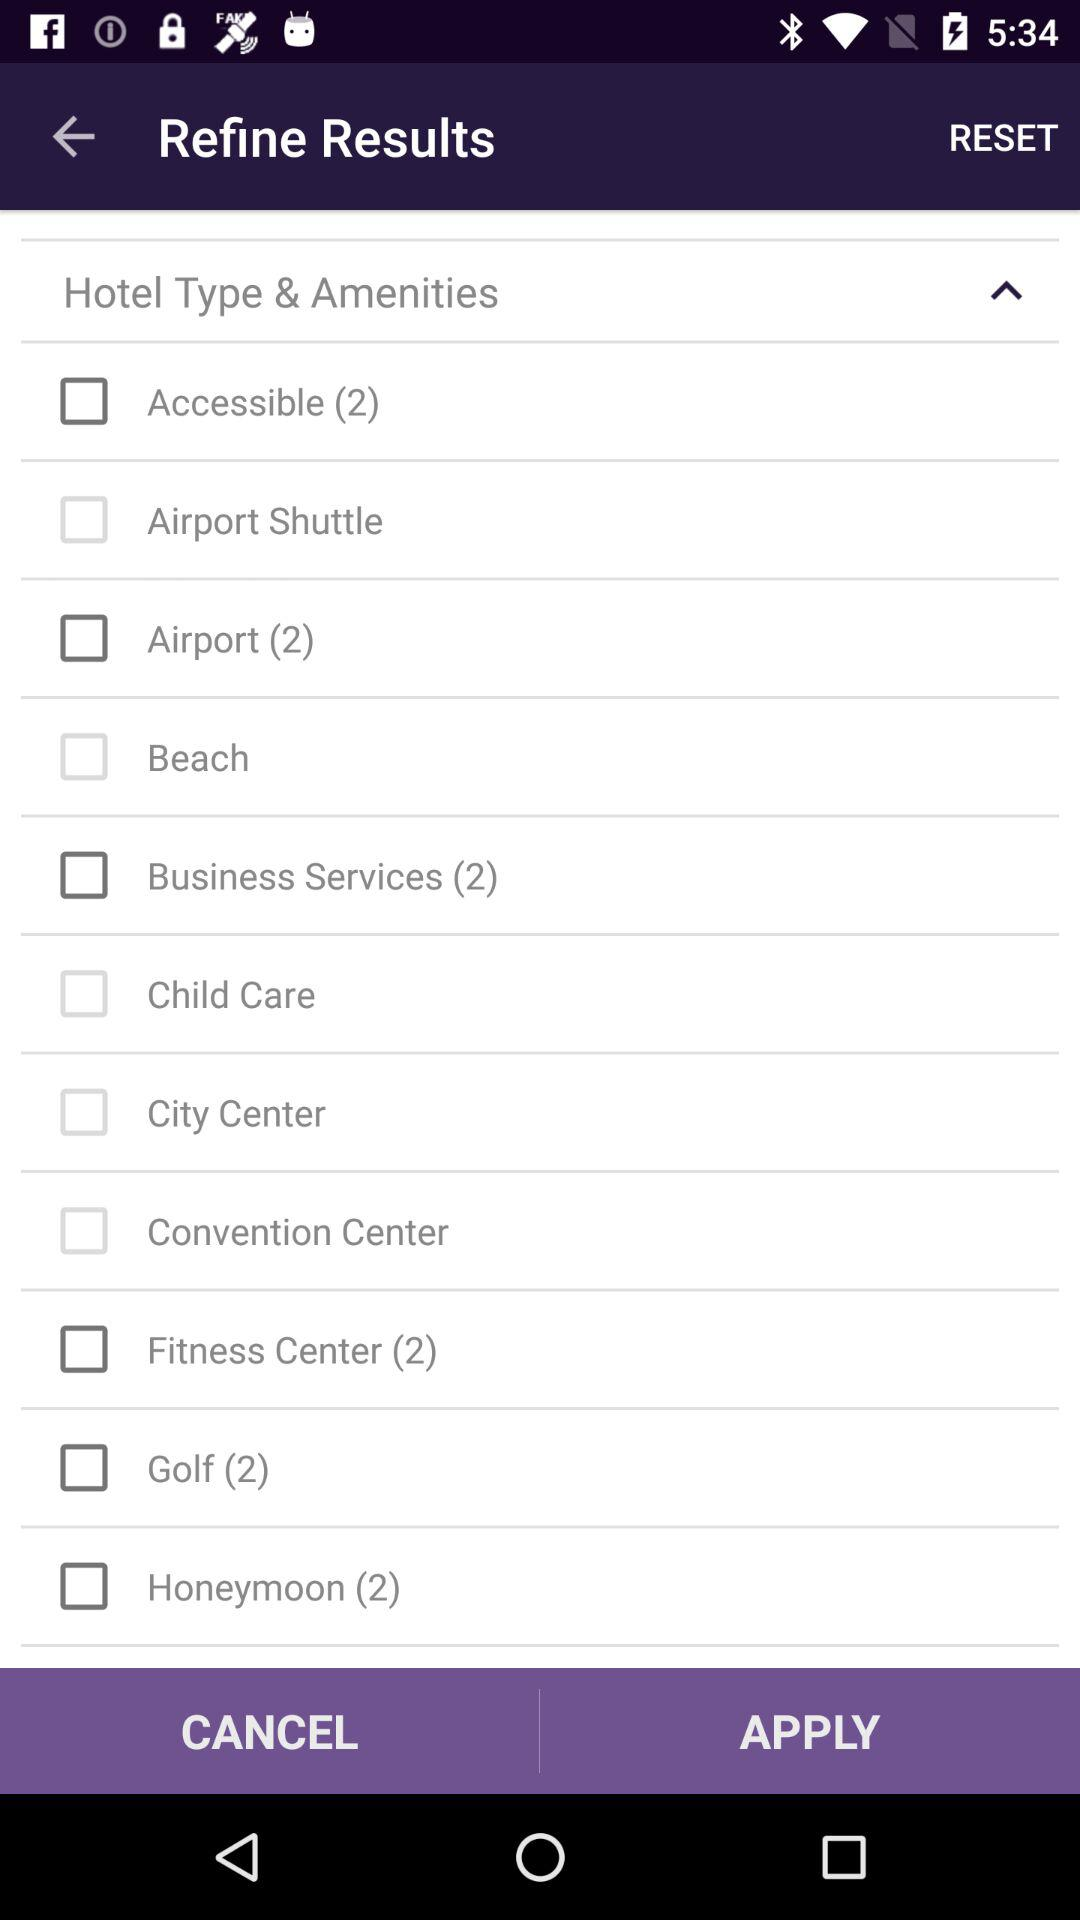Is "Hotel Type & Amenities" checked or unchecked?
When the provided information is insufficient, respond with <no answer>. <no answer> 